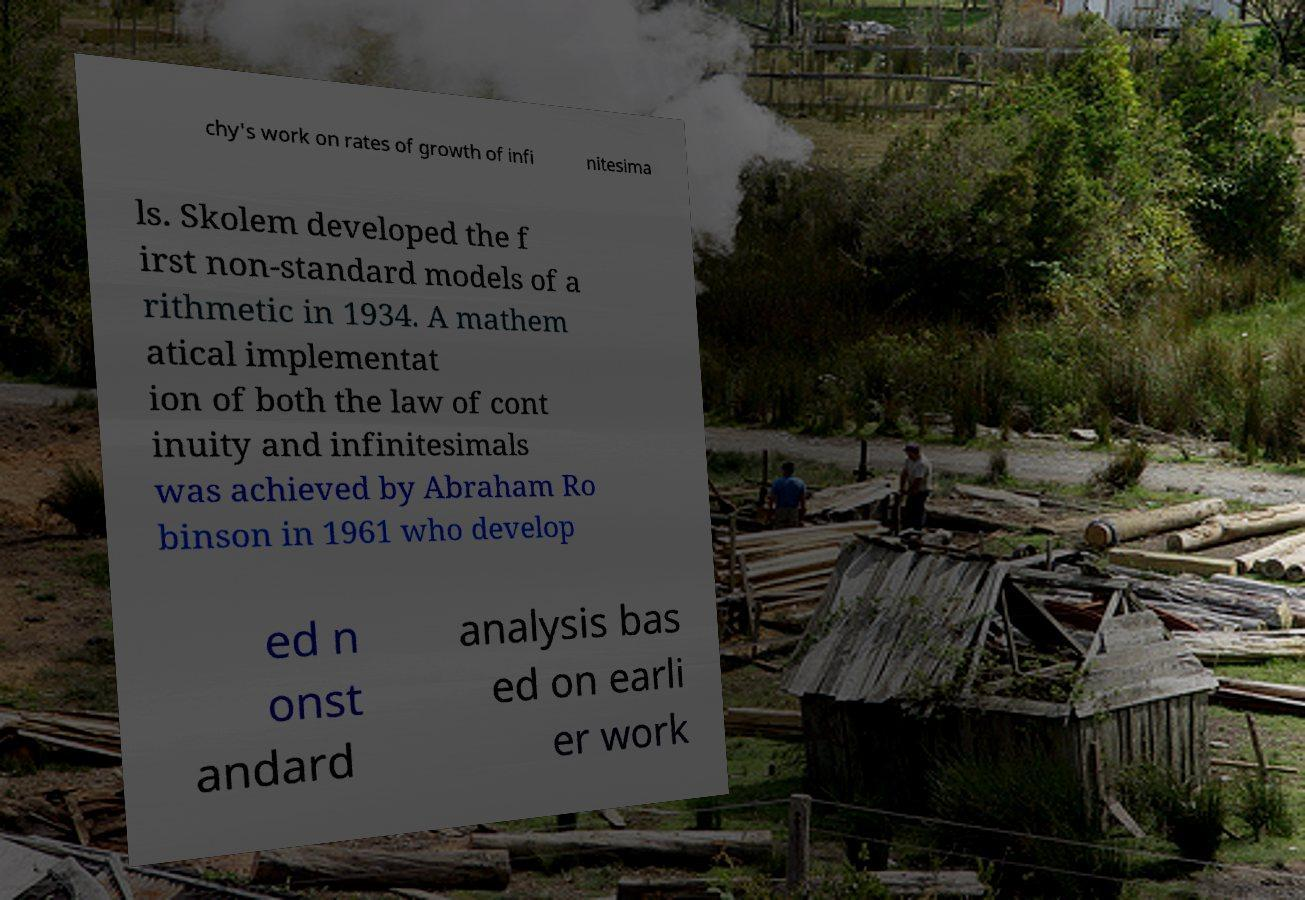Can you read and provide the text displayed in the image?This photo seems to have some interesting text. Can you extract and type it out for me? chy's work on rates of growth of infi nitesima ls. Skolem developed the f irst non-standard models of a rithmetic in 1934. A mathem atical implementat ion of both the law of cont inuity and infinitesimals was achieved by Abraham Ro binson in 1961 who develop ed n onst andard analysis bas ed on earli er work 